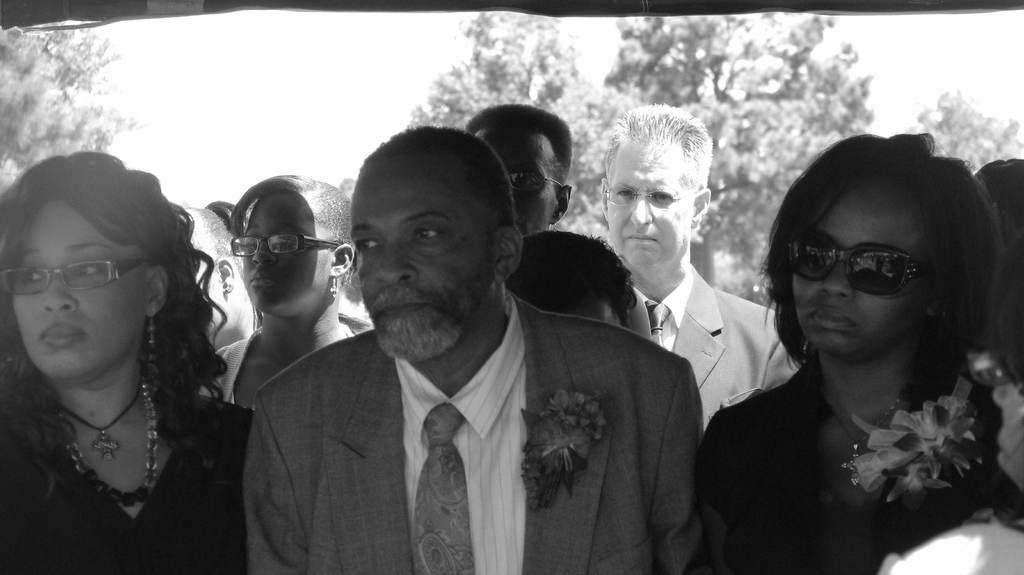How many people are in the image? There is a group of people in the image, but the exact number is not specified. What is the position of the people in the image? The people are standing on the ground in the image. What can be seen in the background of the image? There are trees and the sky visible in the background of the image. Can you determine the time of day the image was taken? The image was likely taken during the day, as the sky is visible and not dark. What type of rod is being used by the people in the image? There is no rod visible in the image; the people are simply standing on the ground. 